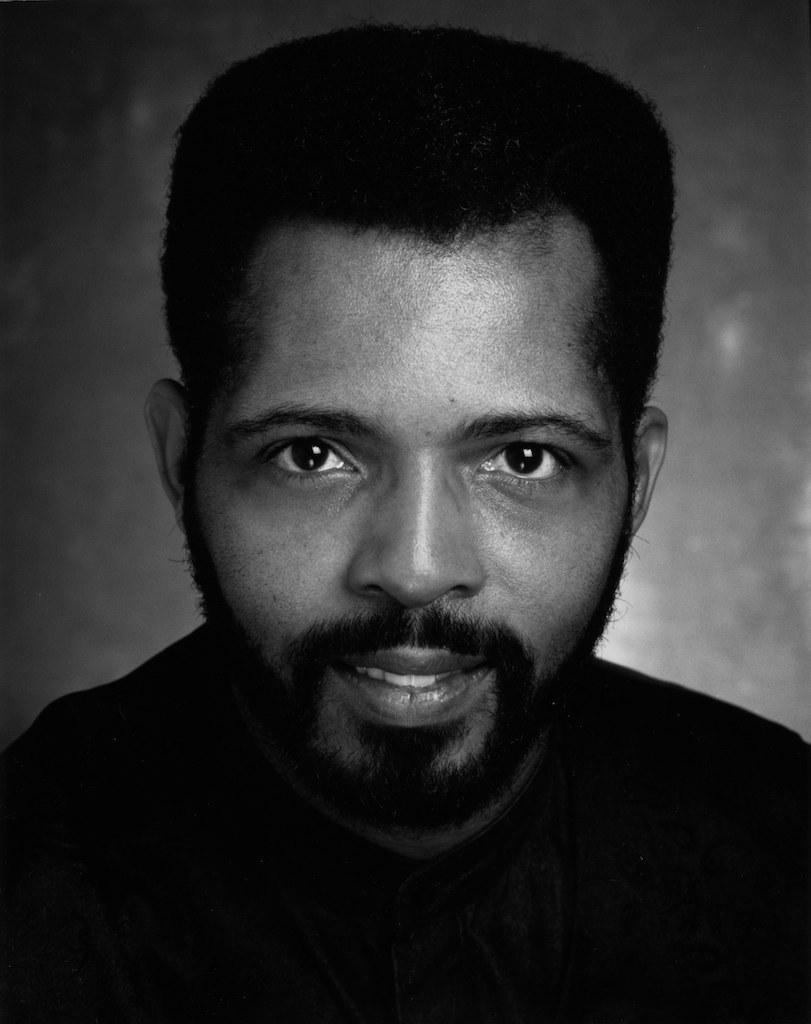What is the main subject of the image? There is a person in the image. What color scheme is used in the image? The image is in black and white. How many cats are visible in the image? There are no cats present in the image. What type of brake is being used by the person in the image? There is no indication of a brake or any action related to braking in the image. 